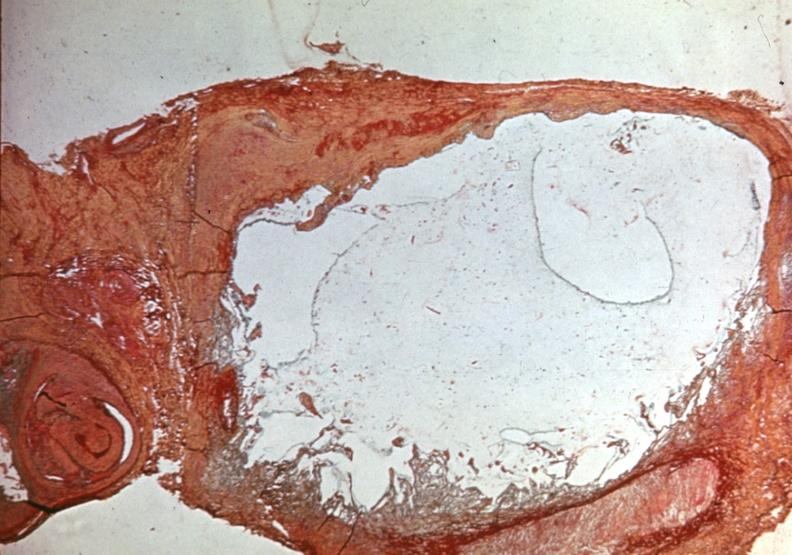s joints present?
Answer the question using a single word or phrase. Yes 